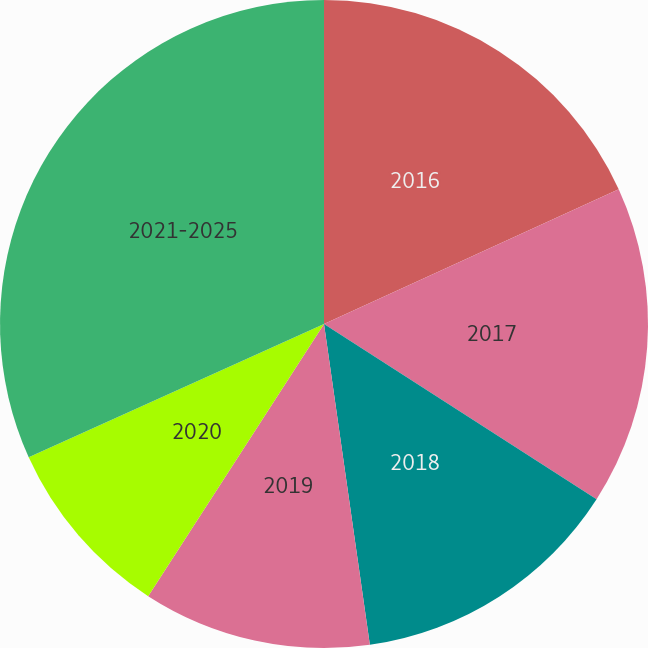Convert chart to OTSL. <chart><loc_0><loc_0><loc_500><loc_500><pie_chart><fcel>2016<fcel>2017<fcel>2018<fcel>2019<fcel>2020<fcel>2021-2025<nl><fcel>18.18%<fcel>15.91%<fcel>13.65%<fcel>11.39%<fcel>9.12%<fcel>31.75%<nl></chart> 